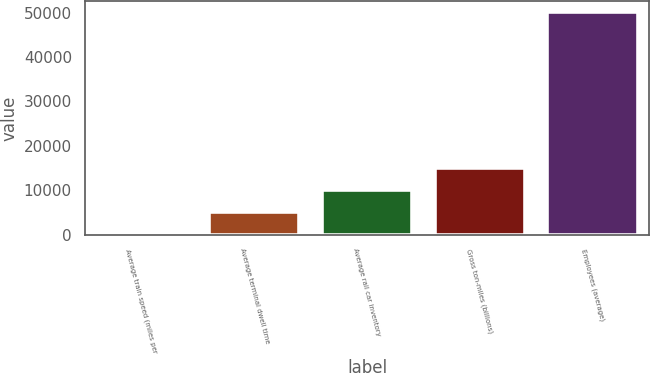<chart> <loc_0><loc_0><loc_500><loc_500><bar_chart><fcel>Average train speed (miles per<fcel>Average terminal dwell time<fcel>Average rail car inventory<fcel>Gross ton-miles (billions)<fcel>Employees (average)<nl><fcel>21.8<fcel>5028.52<fcel>10035.2<fcel>15042<fcel>50089<nl></chart> 